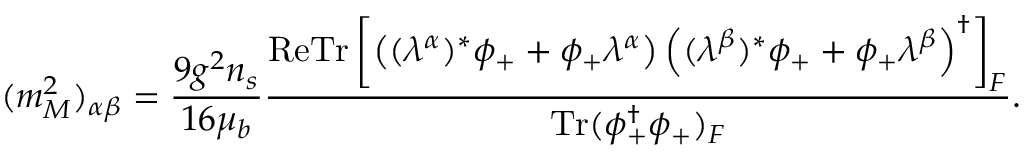Convert formula to latex. <formula><loc_0><loc_0><loc_500><loc_500>( m _ { M } ^ { 2 } ) _ { \alpha \beta } = \frac { 9 g ^ { 2 } n _ { s } } { 1 6 \mu _ { b } } \frac { R e T r \left [ \left ( ( \lambda ^ { \alpha } ) ^ { * } \phi _ { + } + \phi _ { + } \lambda ^ { \alpha } \right ) \left ( ( \lambda ^ { \beta } ) ^ { * } \phi _ { + } + \phi _ { + } \lambda ^ { \beta } \right ) ^ { \dagger } \right ] _ { F } } { T r ( \phi _ { + } ^ { \dagger } \phi _ { + } ) _ { F } } .</formula> 